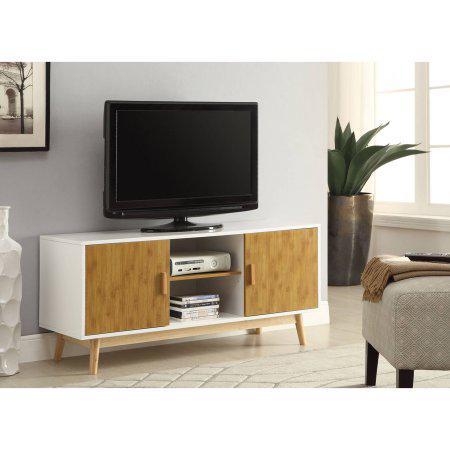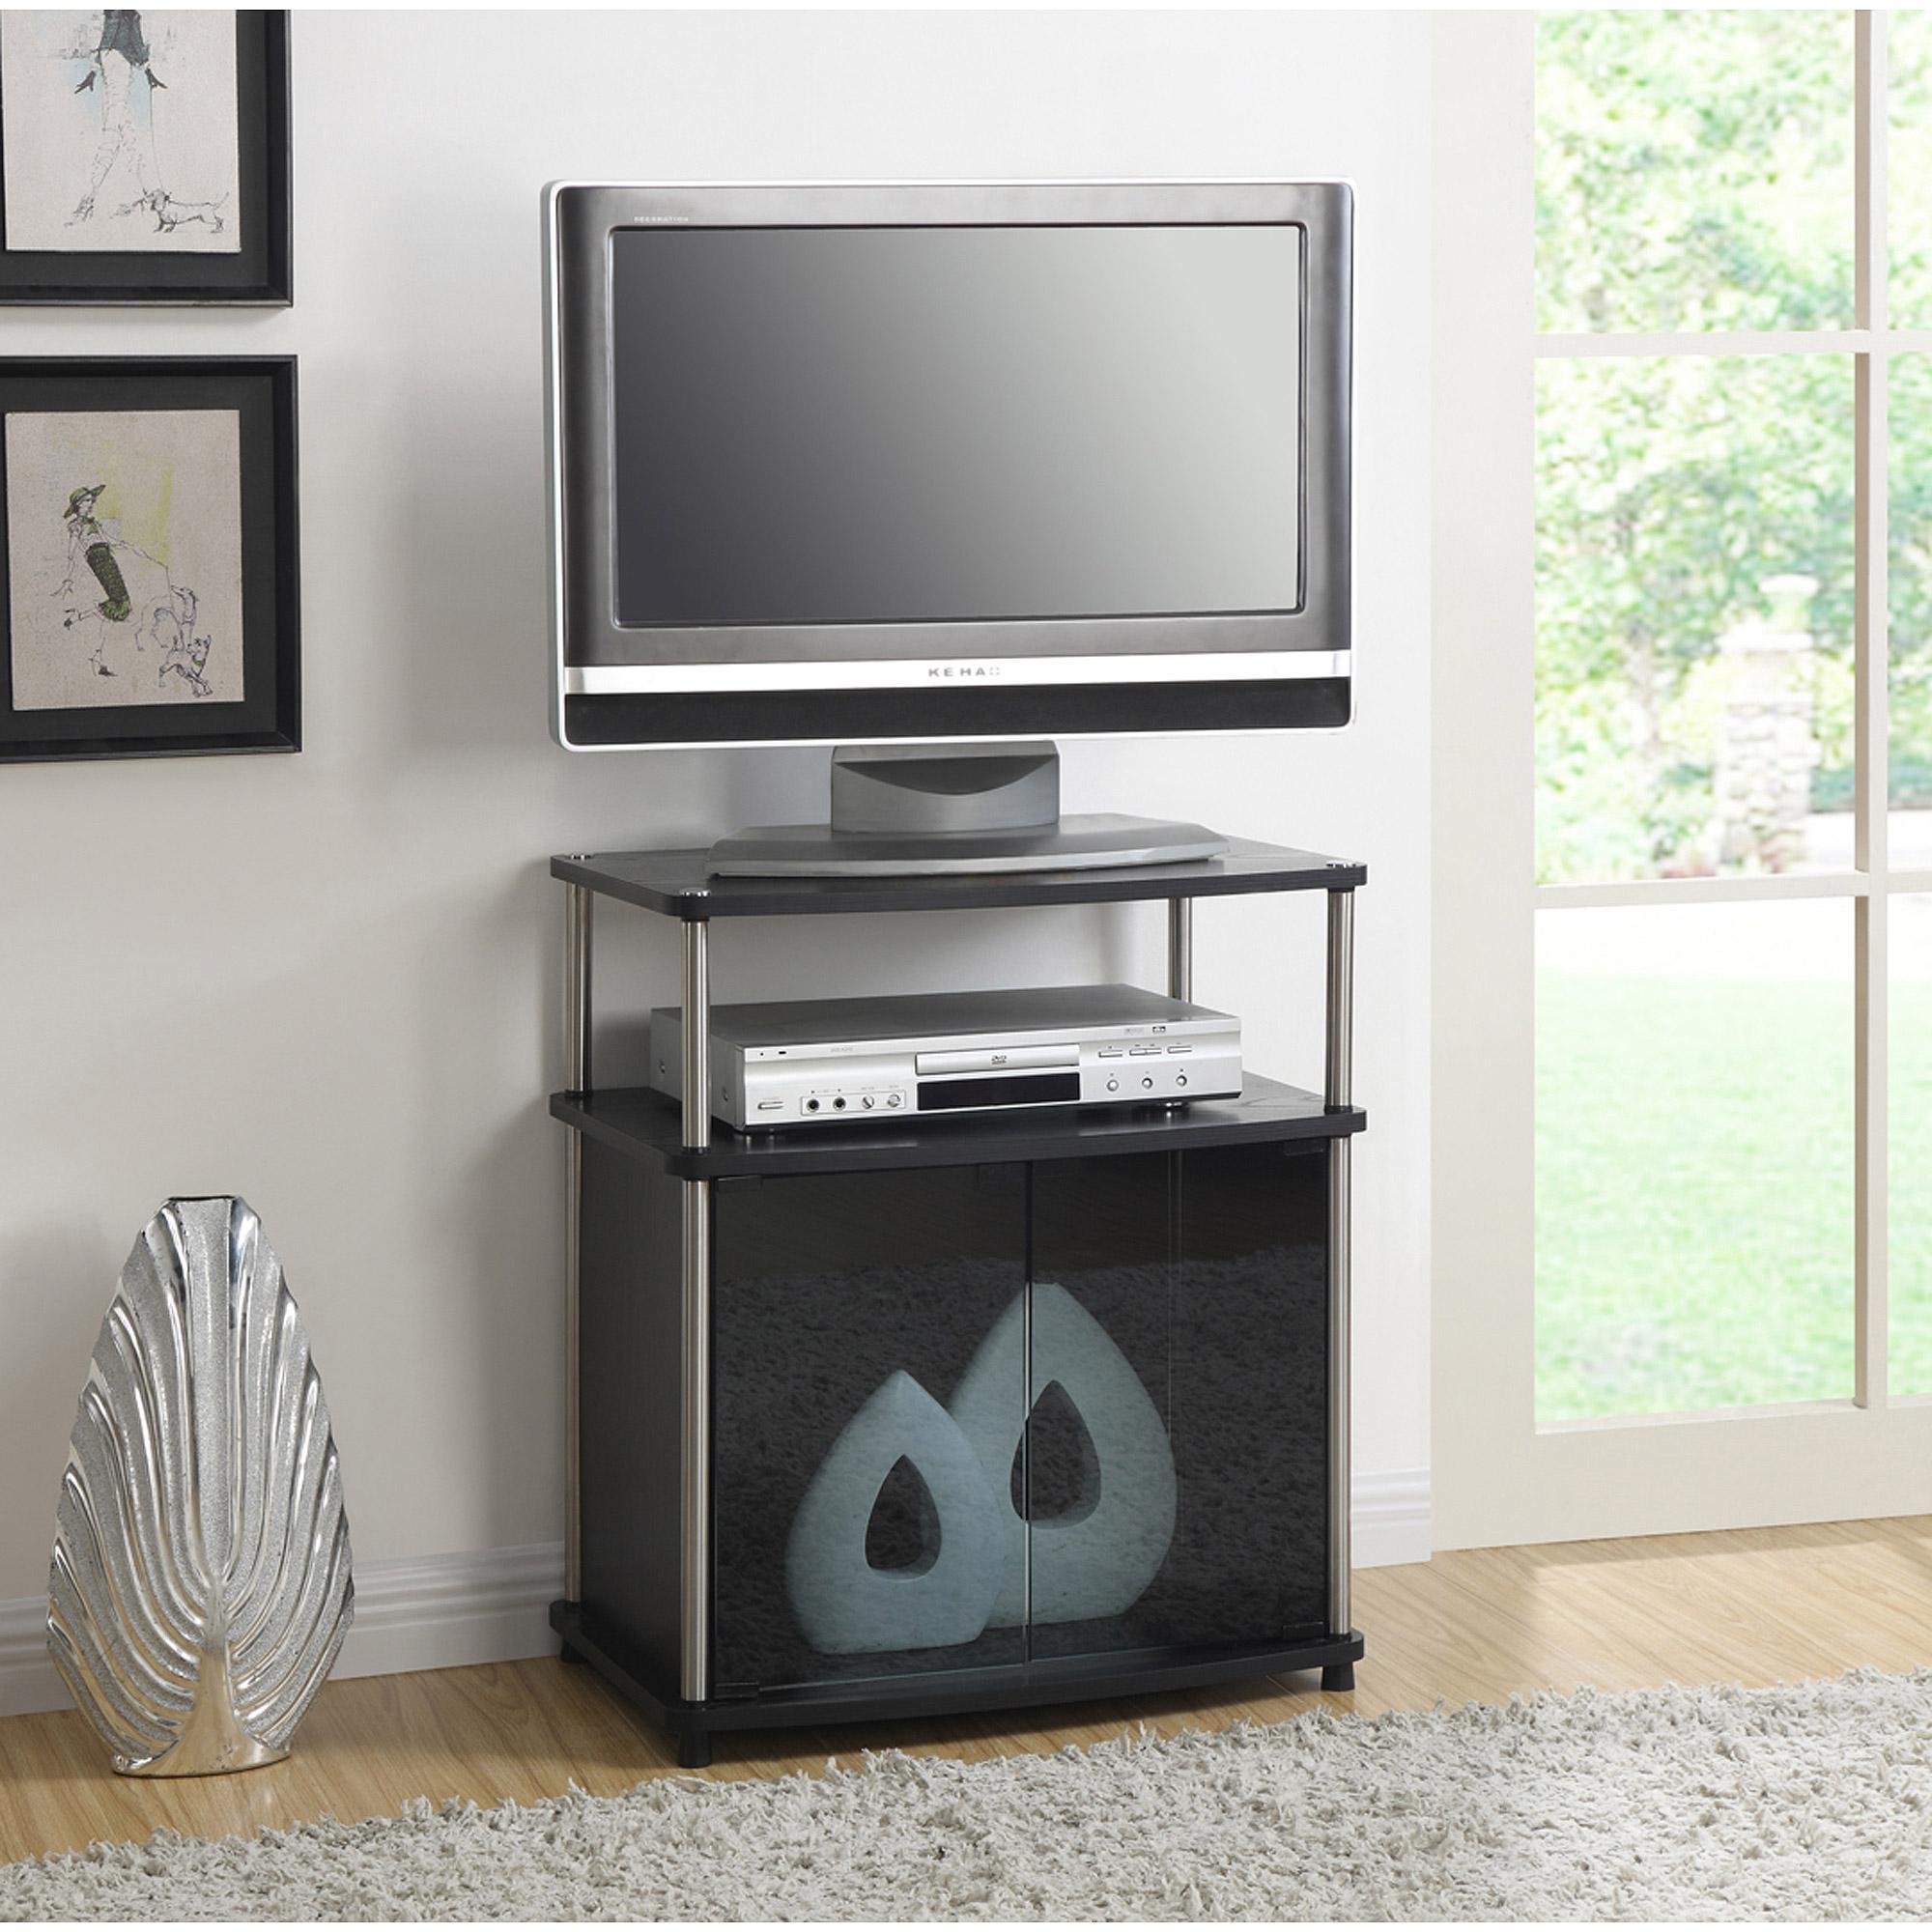The first image is the image on the left, the second image is the image on the right. For the images shown, is this caption "Only one of the televisions appears to be reflecting light; the other tv is completely dark." true? Answer yes or no. Yes. 